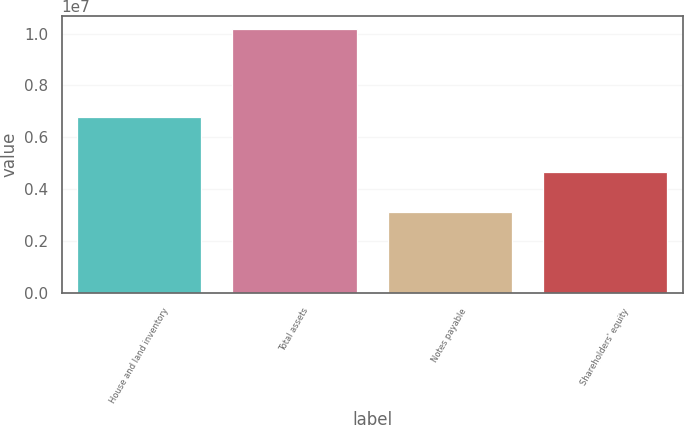Convert chart to OTSL. <chart><loc_0><loc_0><loc_500><loc_500><bar_chart><fcel>House and land inventory<fcel>Total assets<fcel>Notes payable<fcel>Shareholders' equity<nl><fcel>6.77066e+06<fcel>1.01782e+07<fcel>3.1293e+06<fcel>4.65936e+06<nl></chart> 